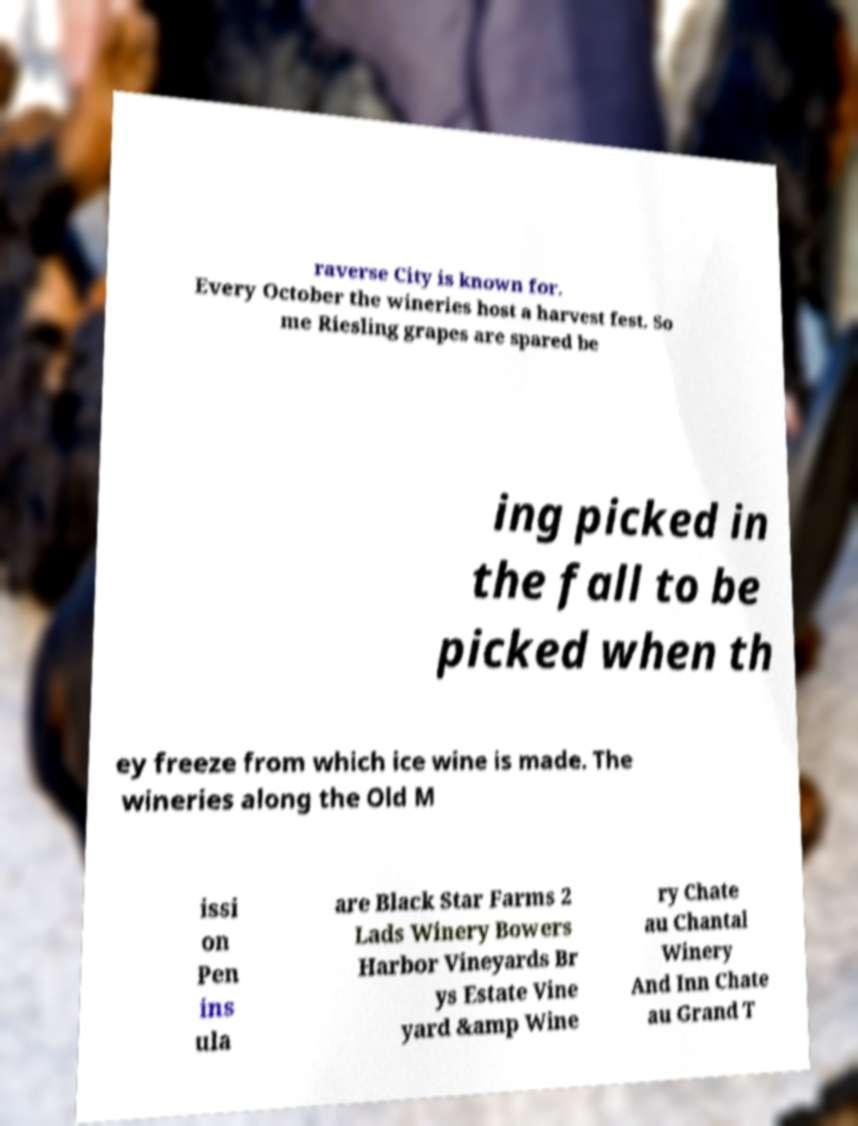Can you accurately transcribe the text from the provided image for me? raverse City is known for. Every October the wineries host a harvest fest. So me Riesling grapes are spared be ing picked in the fall to be picked when th ey freeze from which ice wine is made. The wineries along the Old M issi on Pen ins ula are Black Star Farms 2 Lads Winery Bowers Harbor Vineyards Br ys Estate Vine yard &amp Wine ry Chate au Chantal Winery And Inn Chate au Grand T 